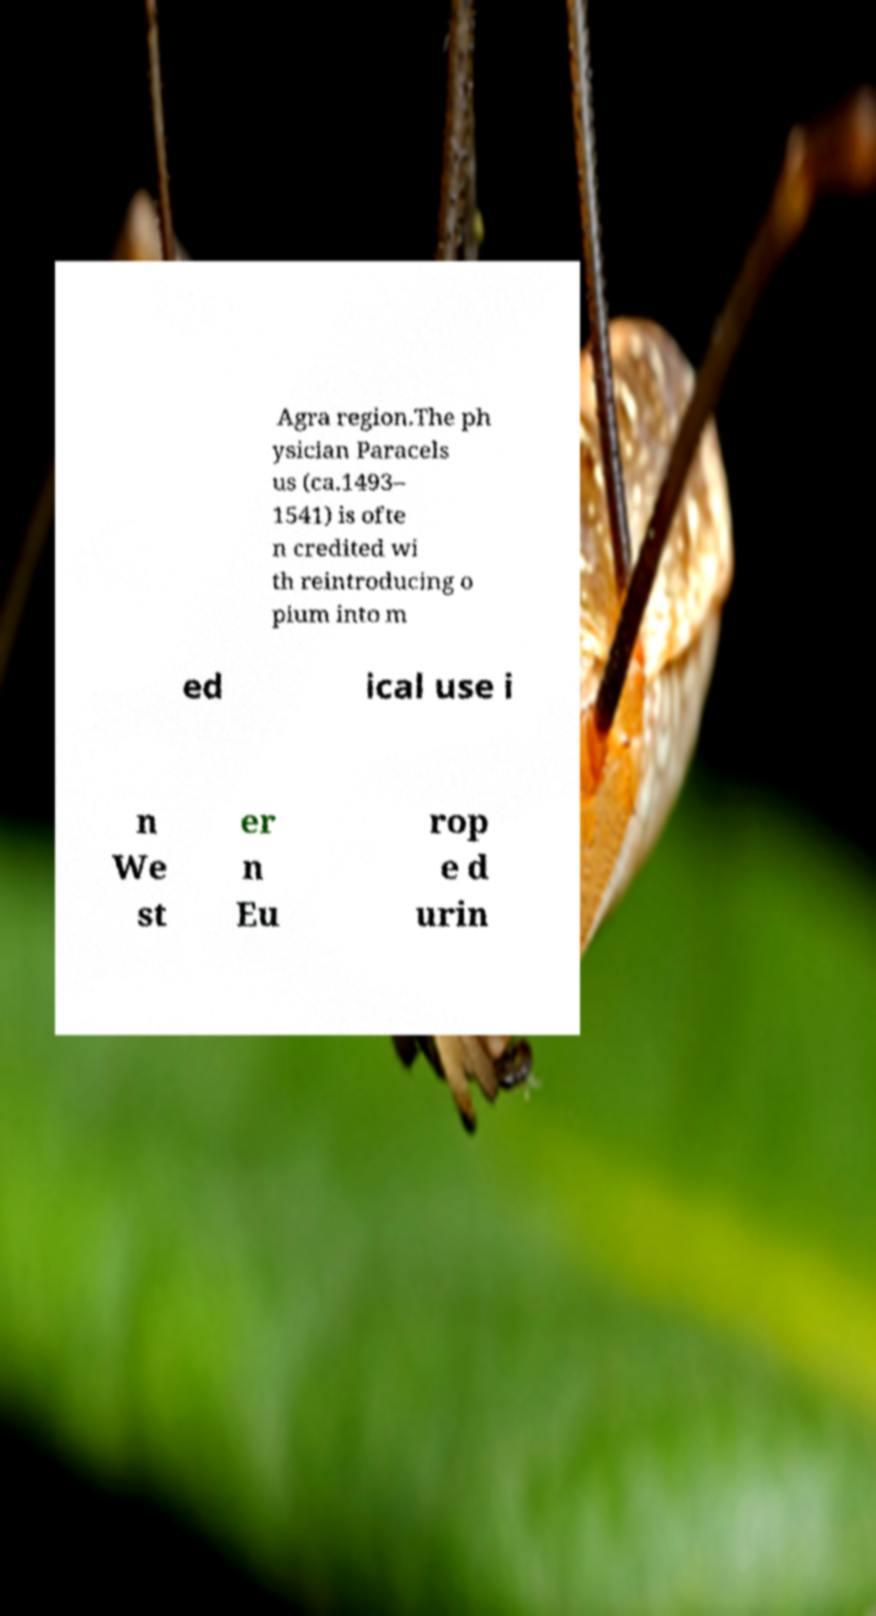Could you extract and type out the text from this image? Agra region.The ph ysician Paracels us (ca.1493– 1541) is ofte n credited wi th reintroducing o pium into m ed ical use i n We st er n Eu rop e d urin 